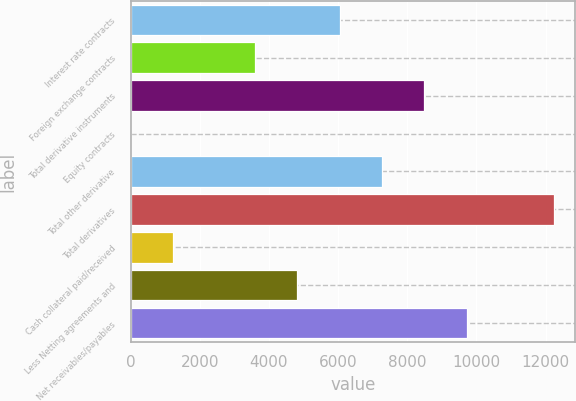Convert chart. <chart><loc_0><loc_0><loc_500><loc_500><bar_chart><fcel>Interest rate contracts<fcel>Foreign exchange contracts<fcel>Total derivative instruments<fcel>Equity contracts<fcel>Total other derivative<fcel>Total derivatives<fcel>Cash collateral paid/received<fcel>Less Netting agreements and<fcel>Net receivables/payables<nl><fcel>6048.2<fcel>3599<fcel>8497.4<fcel>6<fcel>7272.8<fcel>12252<fcel>1230.6<fcel>4823.6<fcel>9722<nl></chart> 